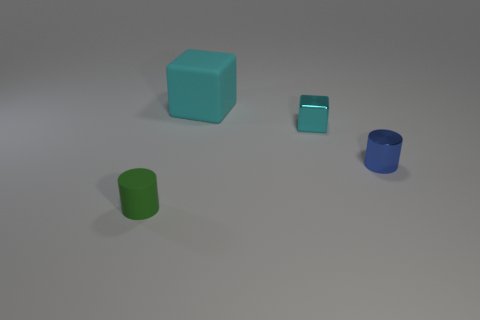Is there any other thing that is the same size as the cyan matte object?
Ensure brevity in your answer.  No. Are there any small brown matte balls?
Keep it short and to the point. No. There is a tiny cylinder to the left of the cyan block on the left side of the small cyan object; what color is it?
Give a very brief answer. Green. How many other objects are the same color as the shiny cylinder?
Ensure brevity in your answer.  0. How many objects are either blue things or metallic objects that are to the right of the cyan shiny block?
Provide a short and direct response. 1. What is the color of the matte thing behind the matte cylinder?
Make the answer very short. Cyan. What shape is the tiny matte thing?
Your answer should be very brief. Cylinder. What material is the cylinder to the left of the blue cylinder that is on the right side of the green object?
Ensure brevity in your answer.  Rubber. What number of other things are there of the same material as the green cylinder
Your answer should be compact. 1. What material is the green cylinder that is the same size as the cyan metallic block?
Offer a very short reply. Rubber. 